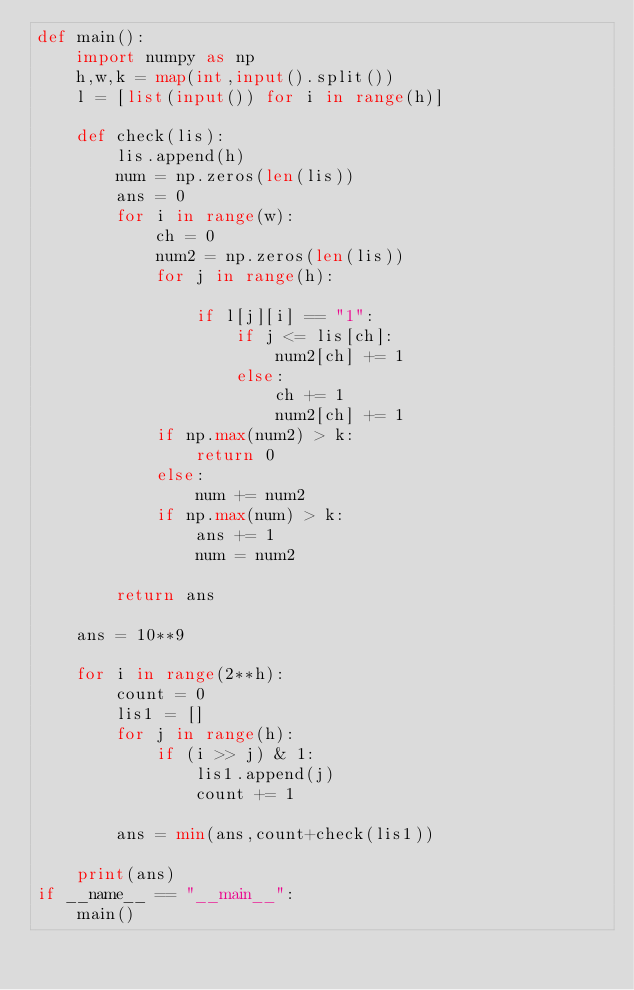<code> <loc_0><loc_0><loc_500><loc_500><_Python_>def main():
    import numpy as np
    h,w,k = map(int,input().split())
    l = [list(input()) for i in range(h)]

    def check(lis):
        lis.append(h)
        num = np.zeros(len(lis))
        ans = 0
        for i in range(w):
            ch = 0
            num2 = np.zeros(len(lis))
            for j in range(h):
                
                if l[j][i] == "1":
                    if j <= lis[ch]:
                        num2[ch] += 1
                    else:
                        ch += 1
                        num2[ch] += 1
            if np.max(num2) > k:
                return 0
            else:
                num += num2
            if np.max(num) > k:
                ans += 1
                num = num2
            
        return ans

    ans = 10**9

    for i in range(2**h):
        count = 0
        lis1 = []
        for j in range(h):
            if (i >> j) & 1:
                lis1.append(j)
                count += 1
        
        ans = min(ans,count+check(lis1))
        
    print(ans)
if __name__ == "__main__":
    main()</code> 